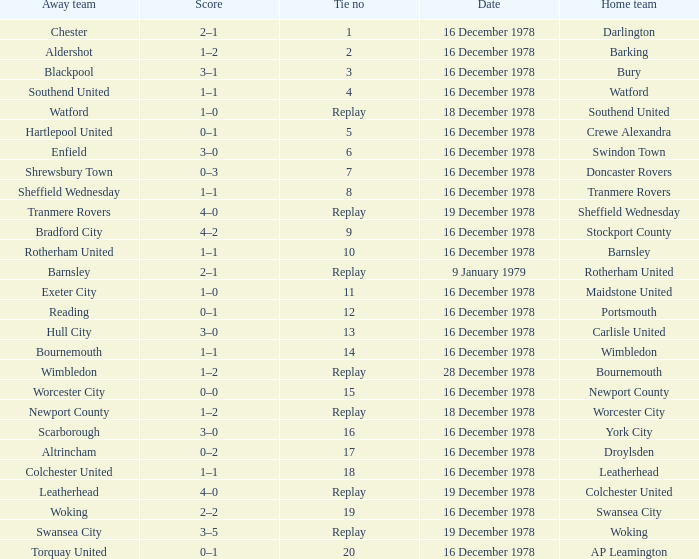What is the tie no for the home team swansea city? 19.0. Would you mind parsing the complete table? {'header': ['Away team', 'Score', 'Tie no', 'Date', 'Home team'], 'rows': [['Chester', '2–1', '1', '16 December 1978', 'Darlington'], ['Aldershot', '1–2', '2', '16 December 1978', 'Barking'], ['Blackpool', '3–1', '3', '16 December 1978', 'Bury'], ['Southend United', '1–1', '4', '16 December 1978', 'Watford'], ['Watford', '1–0', 'Replay', '18 December 1978', 'Southend United'], ['Hartlepool United', '0–1', '5', '16 December 1978', 'Crewe Alexandra'], ['Enfield', '3–0', '6', '16 December 1978', 'Swindon Town'], ['Shrewsbury Town', '0–3', '7', '16 December 1978', 'Doncaster Rovers'], ['Sheffield Wednesday', '1–1', '8', '16 December 1978', 'Tranmere Rovers'], ['Tranmere Rovers', '4–0', 'Replay', '19 December 1978', 'Sheffield Wednesday'], ['Bradford City', '4–2', '9', '16 December 1978', 'Stockport County'], ['Rotherham United', '1–1', '10', '16 December 1978', 'Barnsley'], ['Barnsley', '2–1', 'Replay', '9 January 1979', 'Rotherham United'], ['Exeter City', '1–0', '11', '16 December 1978', 'Maidstone United'], ['Reading', '0–1', '12', '16 December 1978', 'Portsmouth'], ['Hull City', '3–0', '13', '16 December 1978', 'Carlisle United'], ['Bournemouth', '1–1', '14', '16 December 1978', 'Wimbledon'], ['Wimbledon', '1–2', 'Replay', '28 December 1978', 'Bournemouth'], ['Worcester City', '0–0', '15', '16 December 1978', 'Newport County'], ['Newport County', '1–2', 'Replay', '18 December 1978', 'Worcester City'], ['Scarborough', '3–0', '16', '16 December 1978', 'York City'], ['Altrincham', '0–2', '17', '16 December 1978', 'Droylsden'], ['Colchester United', '1–1', '18', '16 December 1978', 'Leatherhead'], ['Leatherhead', '4–0', 'Replay', '19 December 1978', 'Colchester United'], ['Woking', '2–2', '19', '16 December 1978', 'Swansea City'], ['Swansea City', '3–5', 'Replay', '19 December 1978', 'Woking'], ['Torquay United', '0–1', '20', '16 December 1978', 'AP Leamington']]} 